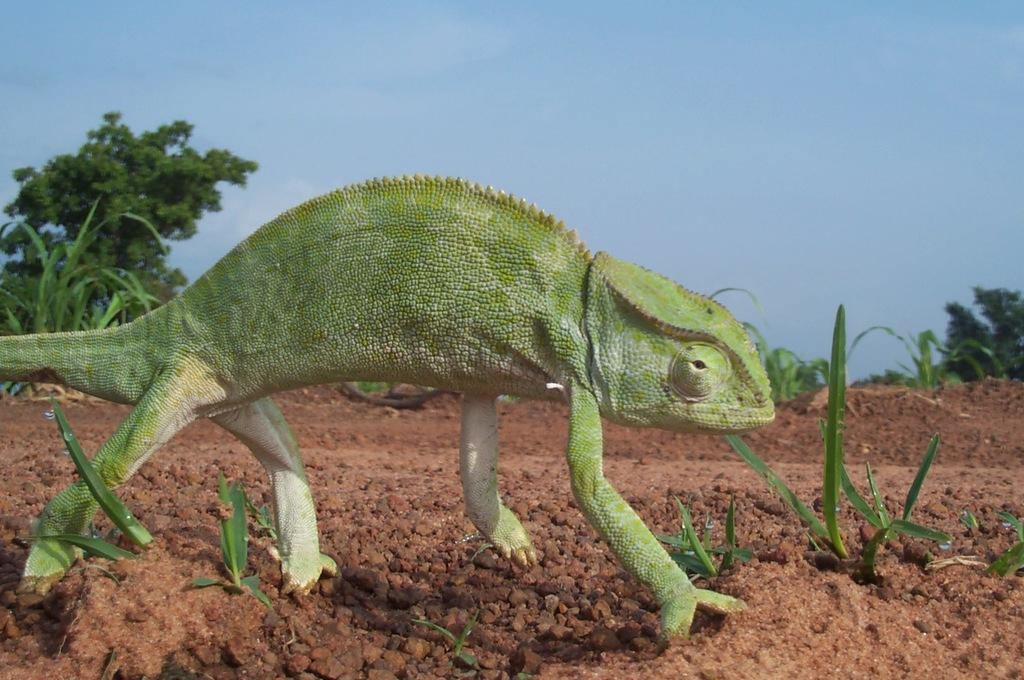What type of animal is on the ground in the image? There is a reptile on the ground in the image. What type of vegetation is visible in the image? There is grass visible in the image. What can be seen in the background of the image? There are trees and the sky visible in the background of the image. What type of cake is being served in the jar in the image? There is no jar or cake present in the image; it features a reptile on the ground and natural elements in the background. How many clams are visible in the image? There are no clams present in the image. 